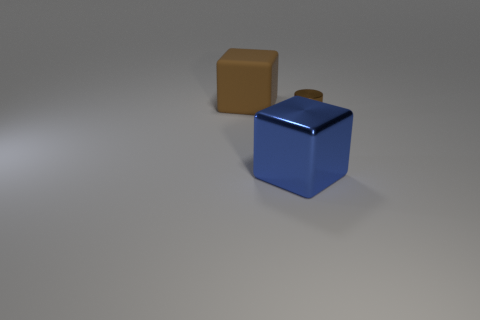Are there any other things that are the same size as the cylinder?
Your response must be concise. No. The thing that is made of the same material as the tiny cylinder is what size?
Ensure brevity in your answer.  Large. What number of objects are blocks behind the tiny cylinder or objects on the left side of the blue cube?
Your answer should be compact. 1. Does the block right of the brown cube have the same size as the brown matte cube?
Keep it short and to the point. Yes. There is a shiny object that is to the left of the brown metal thing; what color is it?
Offer a terse response. Blue. What color is the other large thing that is the same shape as the large blue metallic thing?
Your response must be concise. Brown. There is a metallic object to the right of the blue metal object in front of the tiny cylinder; how many big things are to the right of it?
Keep it short and to the point. 0. Is there anything else that has the same material as the brown cylinder?
Keep it short and to the point. Yes. Is the number of brown cubes on the right side of the small metal object less than the number of tiny metal things?
Offer a terse response. Yes. Is the color of the big metal object the same as the small object?
Your answer should be very brief. No. 